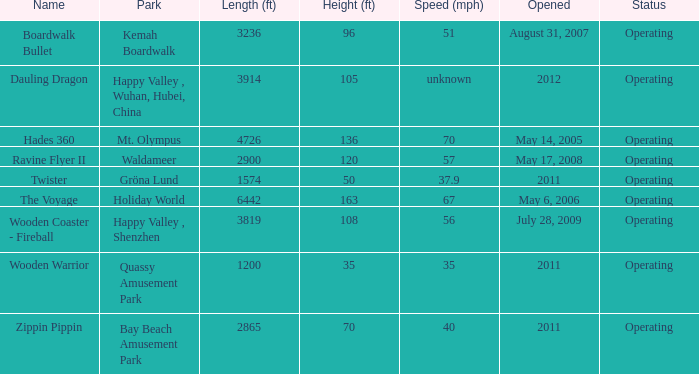How long is the rollar coaster on Kemah Boardwalk 3236.0. Parse the full table. {'header': ['Name', 'Park', 'Length (ft)', 'Height (ft)', 'Speed (mph)', 'Opened', 'Status'], 'rows': [['Boardwalk Bullet', 'Kemah Boardwalk', '3236', '96', '51', 'August 31, 2007', 'Operating'], ['Dauling Dragon', 'Happy Valley , Wuhan, Hubei, China', '3914', '105', 'unknown', '2012', 'Operating'], ['Hades 360', 'Mt. Olympus', '4726', '136', '70', 'May 14, 2005', 'Operating'], ['Ravine Flyer II', 'Waldameer', '2900', '120', '57', 'May 17, 2008', 'Operating'], ['Twister', 'Gröna Lund', '1574', '50', '37.9', '2011', 'Operating'], ['The Voyage', 'Holiday World', '6442', '163', '67', 'May 6, 2006', 'Operating'], ['Wooden Coaster - Fireball', 'Happy Valley , Shenzhen', '3819', '108', '56', 'July 28, 2009', 'Operating'], ['Wooden Warrior', 'Quassy Amusement Park', '1200', '35', '35', '2011', 'Operating'], ['Zippin Pippin', 'Bay Beach Amusement Park', '2865', '70', '40', '2011', 'Operating']]} 